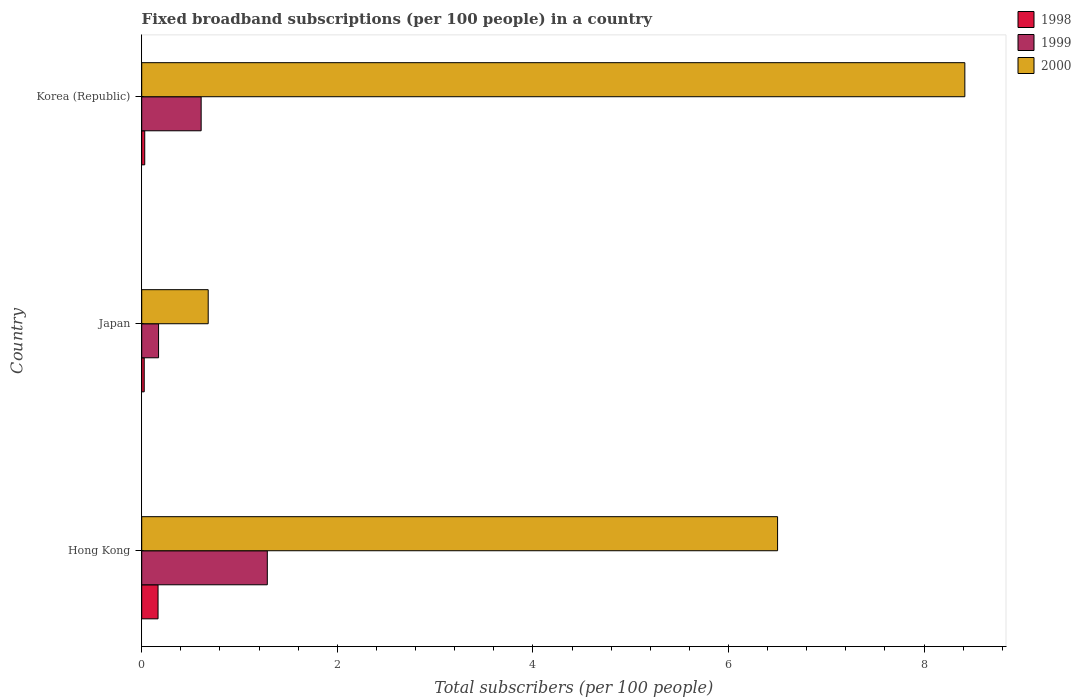How many different coloured bars are there?
Your answer should be compact. 3. Are the number of bars per tick equal to the number of legend labels?
Make the answer very short. Yes. How many bars are there on the 2nd tick from the top?
Ensure brevity in your answer.  3. What is the label of the 2nd group of bars from the top?
Offer a terse response. Japan. In how many cases, is the number of bars for a given country not equal to the number of legend labels?
Give a very brief answer. 0. What is the number of broadband subscriptions in 1999 in Japan?
Make the answer very short. 0.17. Across all countries, what is the maximum number of broadband subscriptions in 1998?
Offer a very short reply. 0.17. Across all countries, what is the minimum number of broadband subscriptions in 2000?
Your answer should be very brief. 0.68. In which country was the number of broadband subscriptions in 1999 maximum?
Ensure brevity in your answer.  Hong Kong. What is the total number of broadband subscriptions in 2000 in the graph?
Your answer should be compact. 15.6. What is the difference between the number of broadband subscriptions in 1999 in Hong Kong and that in Korea (Republic)?
Your response must be concise. 0.68. What is the difference between the number of broadband subscriptions in 1998 in Japan and the number of broadband subscriptions in 1999 in Hong Kong?
Your answer should be compact. -1.26. What is the average number of broadband subscriptions in 1999 per country?
Keep it short and to the point. 0.69. What is the difference between the number of broadband subscriptions in 1999 and number of broadband subscriptions in 2000 in Japan?
Make the answer very short. -0.51. In how many countries, is the number of broadband subscriptions in 1998 greater than 7.2 ?
Keep it short and to the point. 0. What is the ratio of the number of broadband subscriptions in 1999 in Japan to that in Korea (Republic)?
Your answer should be compact. 0.28. What is the difference between the highest and the second highest number of broadband subscriptions in 1999?
Provide a short and direct response. 0.68. What is the difference between the highest and the lowest number of broadband subscriptions in 1999?
Offer a very short reply. 1.11. In how many countries, is the number of broadband subscriptions in 2000 greater than the average number of broadband subscriptions in 2000 taken over all countries?
Your answer should be compact. 2. What does the 2nd bar from the top in Hong Kong represents?
Ensure brevity in your answer.  1999. Is it the case that in every country, the sum of the number of broadband subscriptions in 2000 and number of broadband subscriptions in 1998 is greater than the number of broadband subscriptions in 1999?
Ensure brevity in your answer.  Yes. How many bars are there?
Keep it short and to the point. 9. Are all the bars in the graph horizontal?
Give a very brief answer. Yes. What is the difference between two consecutive major ticks on the X-axis?
Offer a terse response. 2. Are the values on the major ticks of X-axis written in scientific E-notation?
Ensure brevity in your answer.  No. Does the graph contain any zero values?
Your answer should be very brief. No. Where does the legend appear in the graph?
Provide a succinct answer. Top right. What is the title of the graph?
Your answer should be compact. Fixed broadband subscriptions (per 100 people) in a country. What is the label or title of the X-axis?
Offer a very short reply. Total subscribers (per 100 people). What is the label or title of the Y-axis?
Make the answer very short. Country. What is the Total subscribers (per 100 people) in 1998 in Hong Kong?
Your response must be concise. 0.17. What is the Total subscribers (per 100 people) in 1999 in Hong Kong?
Offer a very short reply. 1.28. What is the Total subscribers (per 100 people) in 2000 in Hong Kong?
Offer a very short reply. 6.5. What is the Total subscribers (per 100 people) of 1998 in Japan?
Provide a short and direct response. 0.03. What is the Total subscribers (per 100 people) of 1999 in Japan?
Offer a very short reply. 0.17. What is the Total subscribers (per 100 people) of 2000 in Japan?
Make the answer very short. 0.68. What is the Total subscribers (per 100 people) of 1998 in Korea (Republic)?
Offer a very short reply. 0.03. What is the Total subscribers (per 100 people) in 1999 in Korea (Republic)?
Offer a very short reply. 0.61. What is the Total subscribers (per 100 people) in 2000 in Korea (Republic)?
Your answer should be compact. 8.42. Across all countries, what is the maximum Total subscribers (per 100 people) in 1998?
Keep it short and to the point. 0.17. Across all countries, what is the maximum Total subscribers (per 100 people) of 1999?
Offer a terse response. 1.28. Across all countries, what is the maximum Total subscribers (per 100 people) in 2000?
Your answer should be very brief. 8.42. Across all countries, what is the minimum Total subscribers (per 100 people) of 1998?
Ensure brevity in your answer.  0.03. Across all countries, what is the minimum Total subscribers (per 100 people) of 1999?
Your answer should be compact. 0.17. Across all countries, what is the minimum Total subscribers (per 100 people) of 2000?
Your answer should be very brief. 0.68. What is the total Total subscribers (per 100 people) of 1998 in the graph?
Offer a terse response. 0.22. What is the total Total subscribers (per 100 people) of 1999 in the graph?
Your response must be concise. 2.06. What is the total Total subscribers (per 100 people) in 2000 in the graph?
Give a very brief answer. 15.6. What is the difference between the Total subscribers (per 100 people) in 1998 in Hong Kong and that in Japan?
Your answer should be compact. 0.14. What is the difference between the Total subscribers (per 100 people) of 1999 in Hong Kong and that in Japan?
Your answer should be very brief. 1.11. What is the difference between the Total subscribers (per 100 people) of 2000 in Hong Kong and that in Japan?
Make the answer very short. 5.82. What is the difference between the Total subscribers (per 100 people) in 1998 in Hong Kong and that in Korea (Republic)?
Keep it short and to the point. 0.14. What is the difference between the Total subscribers (per 100 people) in 1999 in Hong Kong and that in Korea (Republic)?
Give a very brief answer. 0.68. What is the difference between the Total subscribers (per 100 people) of 2000 in Hong Kong and that in Korea (Republic)?
Offer a very short reply. -1.91. What is the difference between the Total subscribers (per 100 people) in 1998 in Japan and that in Korea (Republic)?
Offer a terse response. -0.01. What is the difference between the Total subscribers (per 100 people) in 1999 in Japan and that in Korea (Republic)?
Ensure brevity in your answer.  -0.44. What is the difference between the Total subscribers (per 100 people) of 2000 in Japan and that in Korea (Republic)?
Give a very brief answer. -7.74. What is the difference between the Total subscribers (per 100 people) of 1998 in Hong Kong and the Total subscribers (per 100 people) of 1999 in Japan?
Give a very brief answer. -0.01. What is the difference between the Total subscribers (per 100 people) of 1998 in Hong Kong and the Total subscribers (per 100 people) of 2000 in Japan?
Offer a very short reply. -0.51. What is the difference between the Total subscribers (per 100 people) of 1999 in Hong Kong and the Total subscribers (per 100 people) of 2000 in Japan?
Make the answer very short. 0.6. What is the difference between the Total subscribers (per 100 people) in 1998 in Hong Kong and the Total subscribers (per 100 people) in 1999 in Korea (Republic)?
Provide a succinct answer. -0.44. What is the difference between the Total subscribers (per 100 people) of 1998 in Hong Kong and the Total subscribers (per 100 people) of 2000 in Korea (Republic)?
Offer a terse response. -8.25. What is the difference between the Total subscribers (per 100 people) of 1999 in Hong Kong and the Total subscribers (per 100 people) of 2000 in Korea (Republic)?
Your response must be concise. -7.13. What is the difference between the Total subscribers (per 100 people) in 1998 in Japan and the Total subscribers (per 100 people) in 1999 in Korea (Republic)?
Your answer should be very brief. -0.58. What is the difference between the Total subscribers (per 100 people) of 1998 in Japan and the Total subscribers (per 100 people) of 2000 in Korea (Republic)?
Offer a terse response. -8.39. What is the difference between the Total subscribers (per 100 people) of 1999 in Japan and the Total subscribers (per 100 people) of 2000 in Korea (Republic)?
Your answer should be very brief. -8.25. What is the average Total subscribers (per 100 people) of 1998 per country?
Your response must be concise. 0.07. What is the average Total subscribers (per 100 people) in 1999 per country?
Provide a succinct answer. 0.69. What is the average Total subscribers (per 100 people) in 2000 per country?
Your answer should be very brief. 5.2. What is the difference between the Total subscribers (per 100 people) in 1998 and Total subscribers (per 100 people) in 1999 in Hong Kong?
Make the answer very short. -1.12. What is the difference between the Total subscribers (per 100 people) of 1998 and Total subscribers (per 100 people) of 2000 in Hong Kong?
Ensure brevity in your answer.  -6.34. What is the difference between the Total subscribers (per 100 people) in 1999 and Total subscribers (per 100 people) in 2000 in Hong Kong?
Your response must be concise. -5.22. What is the difference between the Total subscribers (per 100 people) in 1998 and Total subscribers (per 100 people) in 1999 in Japan?
Offer a terse response. -0.15. What is the difference between the Total subscribers (per 100 people) of 1998 and Total subscribers (per 100 people) of 2000 in Japan?
Keep it short and to the point. -0.65. What is the difference between the Total subscribers (per 100 people) in 1999 and Total subscribers (per 100 people) in 2000 in Japan?
Provide a short and direct response. -0.51. What is the difference between the Total subscribers (per 100 people) of 1998 and Total subscribers (per 100 people) of 1999 in Korea (Republic)?
Your answer should be very brief. -0.58. What is the difference between the Total subscribers (per 100 people) in 1998 and Total subscribers (per 100 people) in 2000 in Korea (Republic)?
Offer a terse response. -8.39. What is the difference between the Total subscribers (per 100 people) in 1999 and Total subscribers (per 100 people) in 2000 in Korea (Republic)?
Make the answer very short. -7.81. What is the ratio of the Total subscribers (per 100 people) in 1998 in Hong Kong to that in Japan?
Keep it short and to the point. 6.53. What is the ratio of the Total subscribers (per 100 people) of 1999 in Hong Kong to that in Japan?
Ensure brevity in your answer.  7.46. What is the ratio of the Total subscribers (per 100 people) of 2000 in Hong Kong to that in Japan?
Offer a terse response. 9.56. What is the ratio of the Total subscribers (per 100 people) in 1998 in Hong Kong to that in Korea (Republic)?
Ensure brevity in your answer.  5.42. What is the ratio of the Total subscribers (per 100 people) of 1999 in Hong Kong to that in Korea (Republic)?
Offer a very short reply. 2.11. What is the ratio of the Total subscribers (per 100 people) in 2000 in Hong Kong to that in Korea (Republic)?
Your answer should be very brief. 0.77. What is the ratio of the Total subscribers (per 100 people) of 1998 in Japan to that in Korea (Republic)?
Provide a succinct answer. 0.83. What is the ratio of the Total subscribers (per 100 people) of 1999 in Japan to that in Korea (Republic)?
Keep it short and to the point. 0.28. What is the ratio of the Total subscribers (per 100 people) in 2000 in Japan to that in Korea (Republic)?
Provide a succinct answer. 0.08. What is the difference between the highest and the second highest Total subscribers (per 100 people) in 1998?
Your answer should be compact. 0.14. What is the difference between the highest and the second highest Total subscribers (per 100 people) in 1999?
Offer a terse response. 0.68. What is the difference between the highest and the second highest Total subscribers (per 100 people) in 2000?
Keep it short and to the point. 1.91. What is the difference between the highest and the lowest Total subscribers (per 100 people) in 1998?
Provide a succinct answer. 0.14. What is the difference between the highest and the lowest Total subscribers (per 100 people) in 1999?
Offer a very short reply. 1.11. What is the difference between the highest and the lowest Total subscribers (per 100 people) in 2000?
Your answer should be very brief. 7.74. 